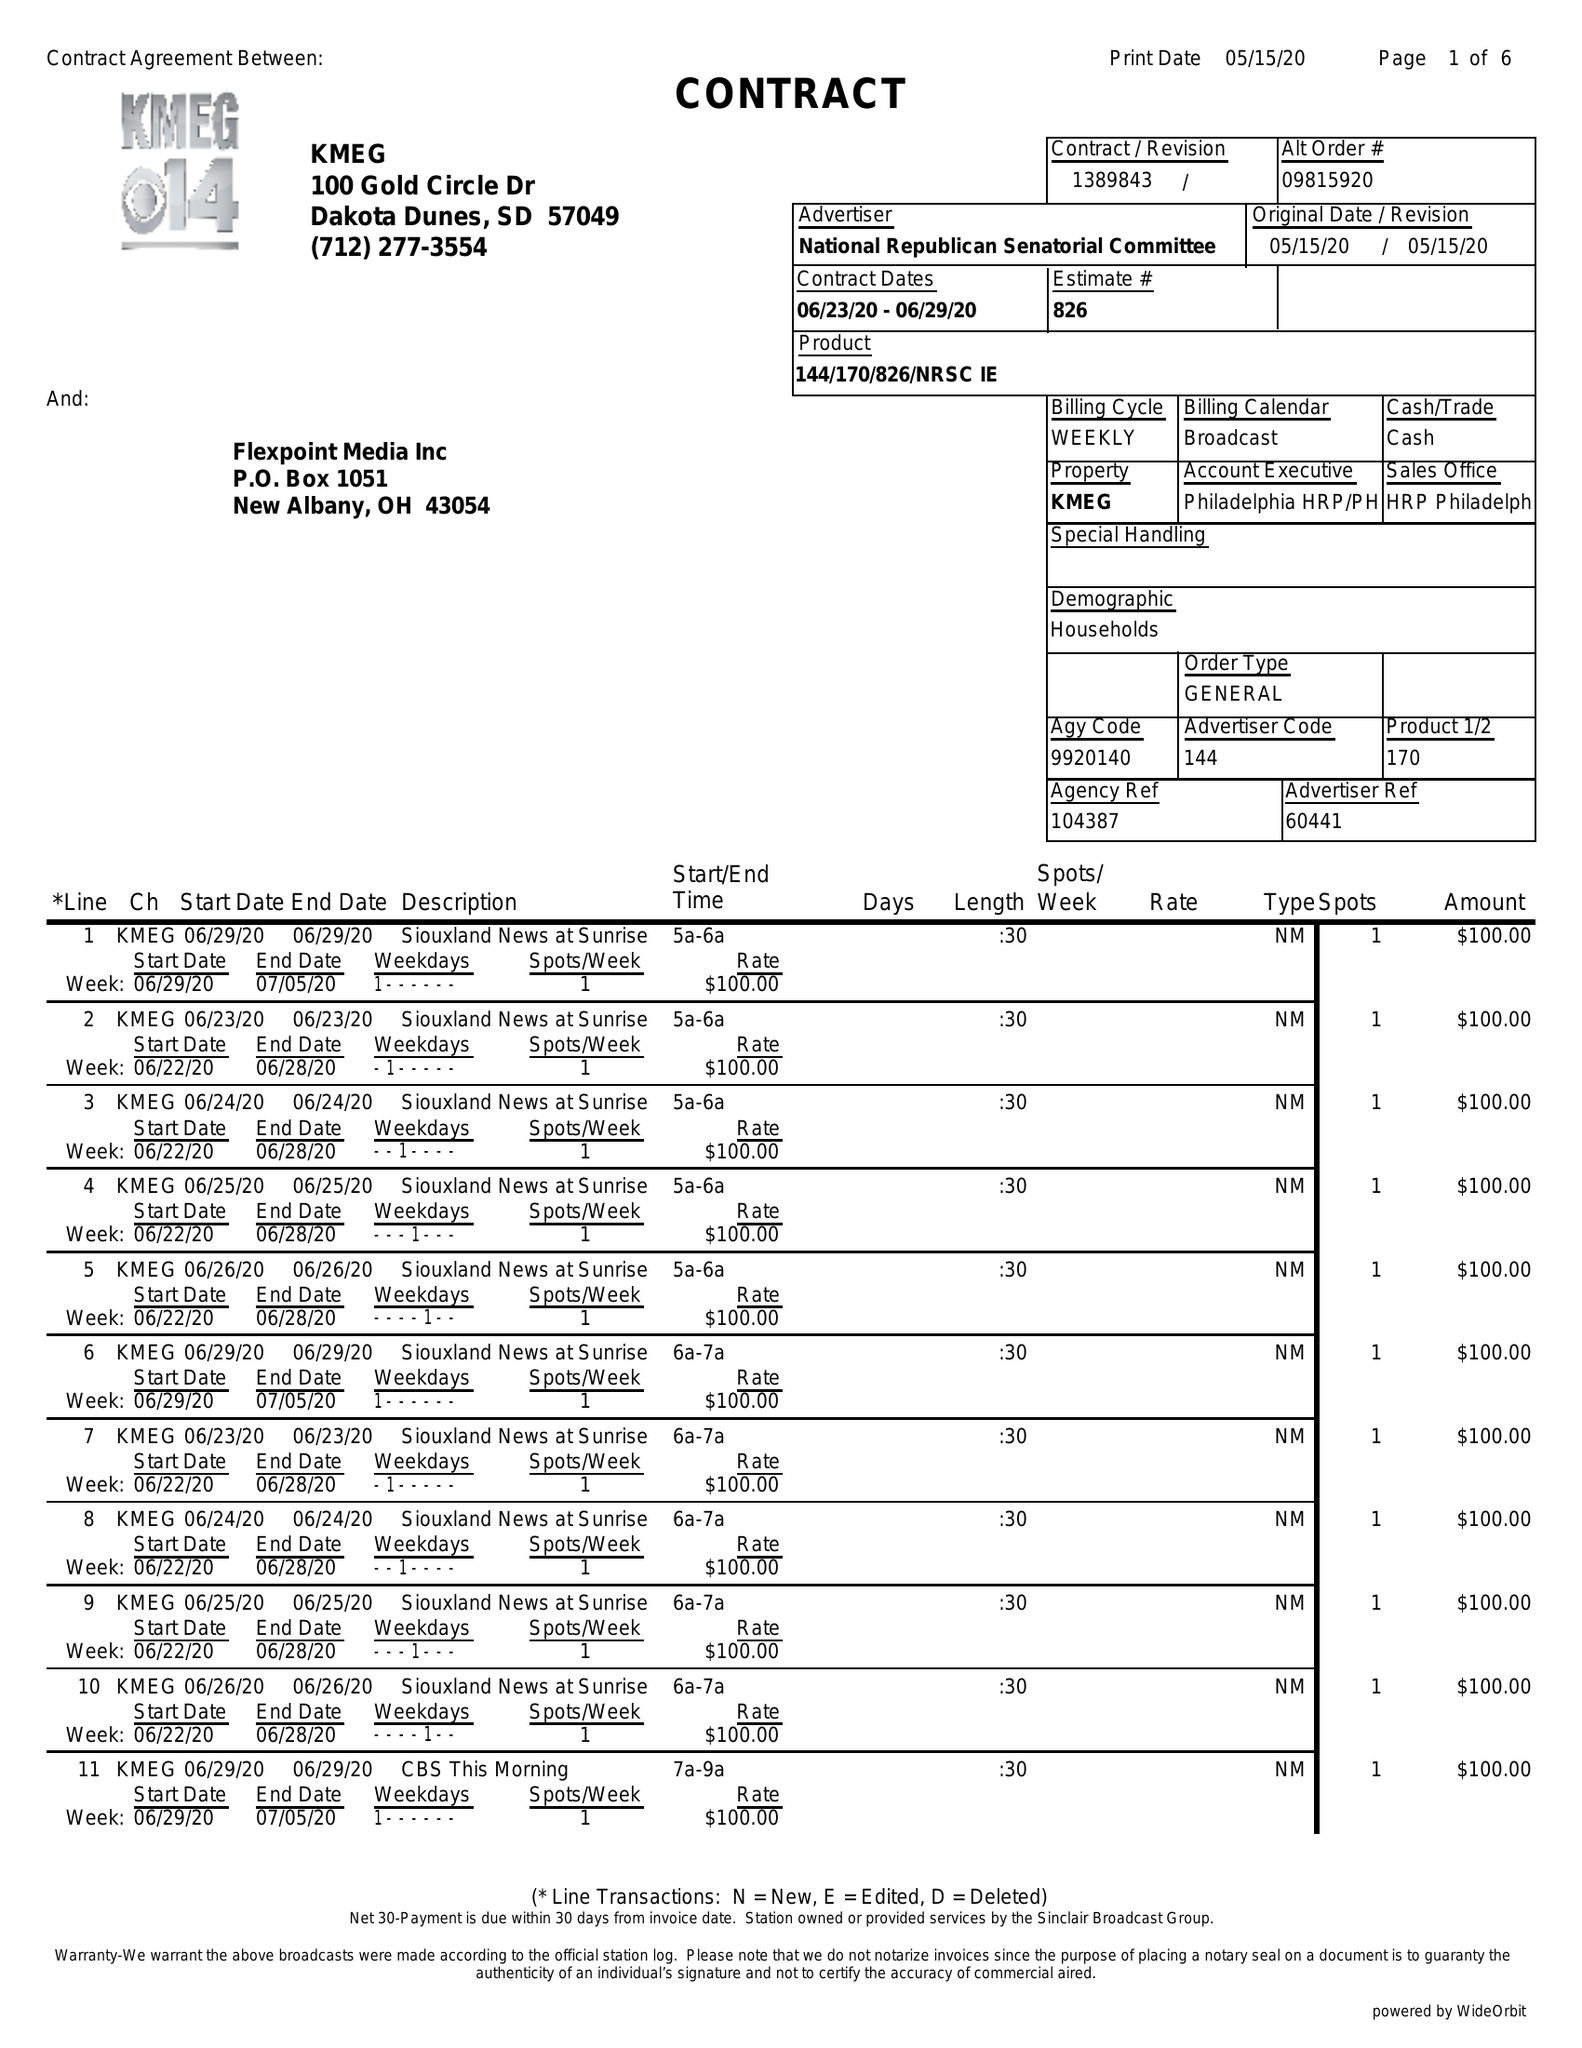What is the value for the contract_num?
Answer the question using a single word or phrase. 1389843 